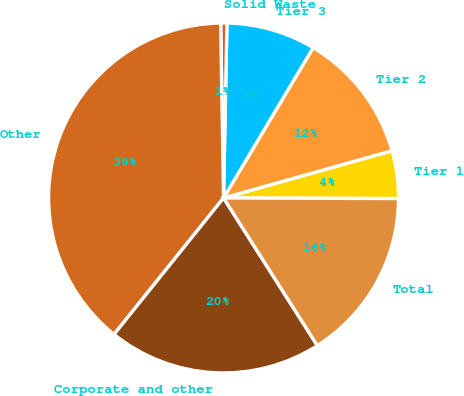<chart> <loc_0><loc_0><loc_500><loc_500><pie_chart><fcel>Tier 1<fcel>Tier 2<fcel>Tier 3<fcel>Solid Waste<fcel>Other<fcel>Corporate and other<fcel>Total<nl><fcel>4.41%<fcel>12.09%<fcel>8.25%<fcel>0.57%<fcel>38.97%<fcel>19.77%<fcel>15.93%<nl></chart> 